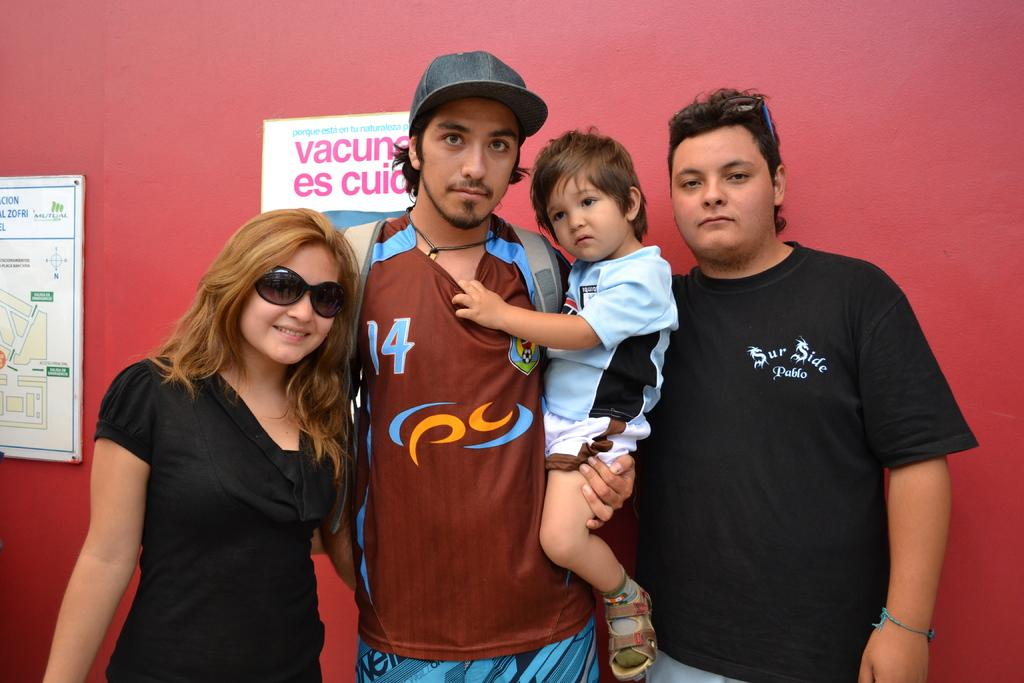How many people are in the image? There are a few people in the image. What color is the wall in the background? There is a red colored wall in the background. What can be found on the wall in the image? There are posters on the wall. What do the posters contain? The posters contain text and images. What type of animal is coiled around the queen's neck in the image? There is no animal or queen present in the image; it features people and posters on a red wall. 